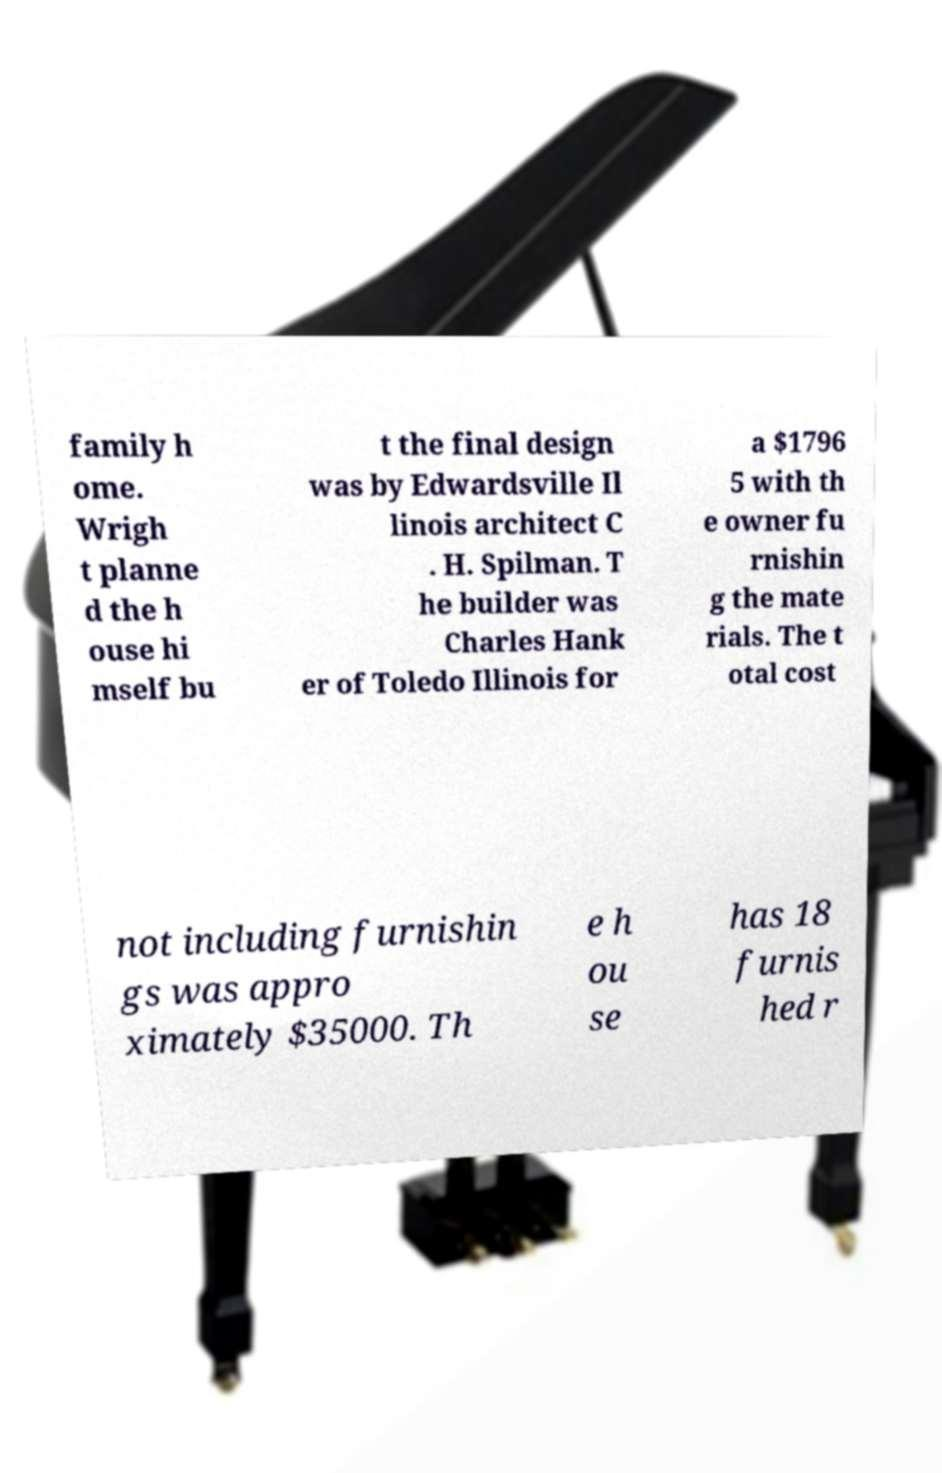Can you read and provide the text displayed in the image?This photo seems to have some interesting text. Can you extract and type it out for me? family h ome. Wrigh t planne d the h ouse hi mself bu t the final design was by Edwardsville Il linois architect C . H. Spilman. T he builder was Charles Hank er of Toledo Illinois for a $1796 5 with th e owner fu rnishin g the mate rials. The t otal cost not including furnishin gs was appro ximately $35000. Th e h ou se has 18 furnis hed r 